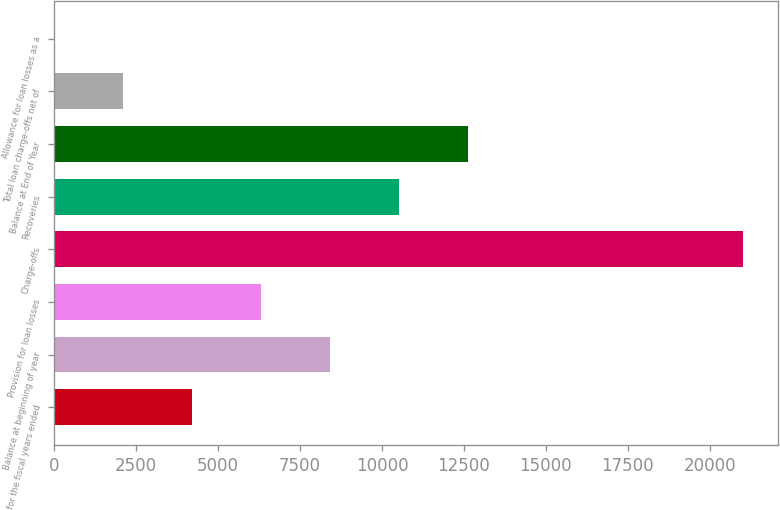Convert chart. <chart><loc_0><loc_0><loc_500><loc_500><bar_chart><fcel>for the fiscal years ended<fcel>Balance at beginning of year<fcel>Provision for loan losses<fcel>Charge-offs<fcel>Recoveries<fcel>Balance at End of Year<fcel>Total loan charge-offs net of<fcel>Allowance for loan losses as a<nl><fcel>4205.76<fcel>8409.58<fcel>6307.67<fcel>21021<fcel>10511.5<fcel>12613.4<fcel>2103.85<fcel>1.94<nl></chart> 